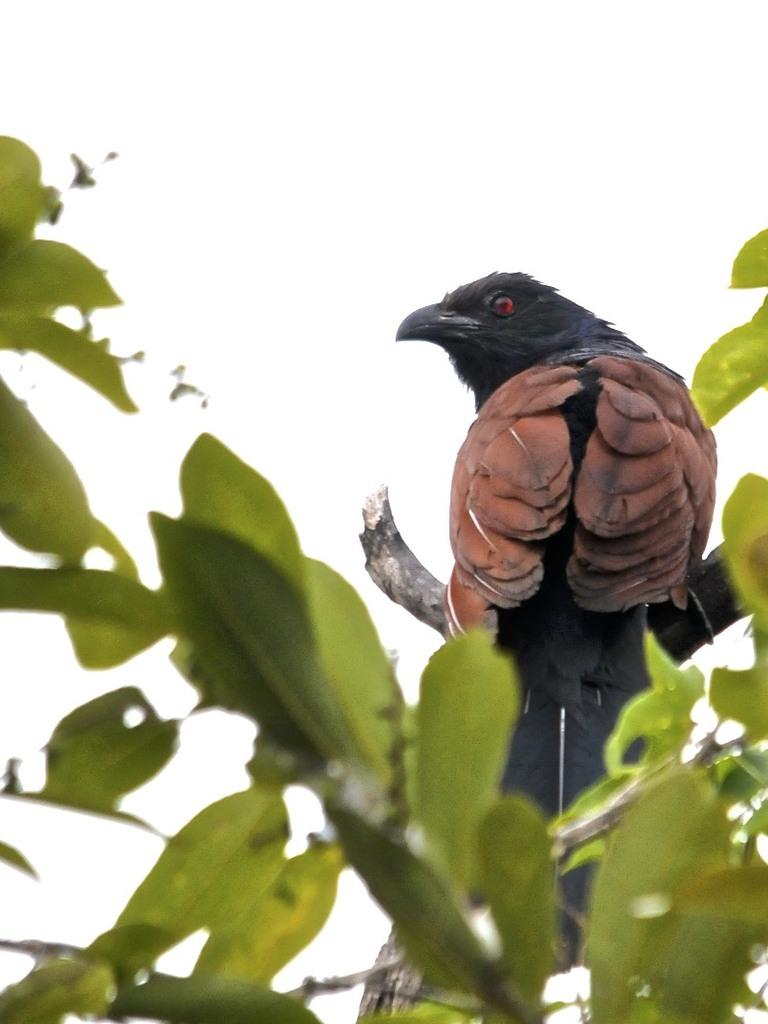What type of animal can be seen in the image? There is a bird in the image. Where is the bird located? The bird is on a tree branch. What else can be seen on the tree in the image? Leaves are visible in the image. What is visible in the background of the image? The sky is visible in the image. What is the weight of the bird in the image? The weight of the bird cannot be determined from the image alone, as it depends on the species and individual bird. 